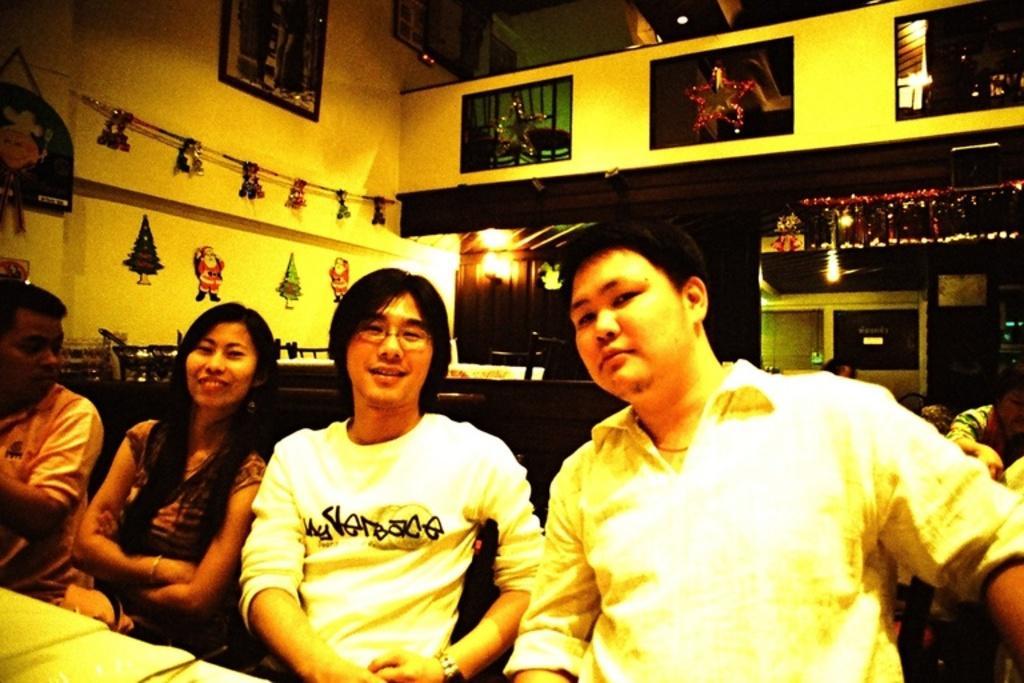How would you summarize this image in a sentence or two? In this picture there are people sitting, in front of these people we can see tables. In the background we can see people, stickers, decorative items, bag, frames on the wall and few objects. 